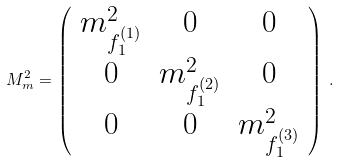<formula> <loc_0><loc_0><loc_500><loc_500>M _ { m } ^ { 2 } = \left ( \begin{array} { c c c } { { m _ { f _ { 1 } ^ { ( 1 ) } } ^ { 2 } } } & { 0 } & { 0 } \\ { 0 } & { { m _ { f _ { 1 } ^ { ( 2 ) } } ^ { 2 } } } & { 0 } \\ { 0 } & { 0 } & { { m _ { f _ { 1 } ^ { ( 3 ) } } ^ { 2 } } } \end{array} \right ) \, .</formula> 